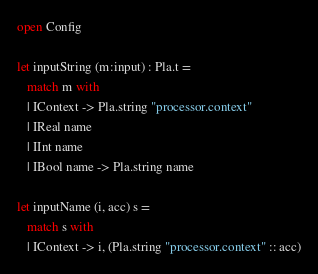Convert code to text. <code><loc_0><loc_0><loc_500><loc_500><_OCaml_>
open Config

let inputString (m:input) : Pla.t =
   match m with
   | IContext -> Pla.string "processor.context"
   | IReal name
   | IInt name
   | IBool name -> Pla.string name

let inputName (i, acc) s =
   match s with
   | IContext -> i, (Pla.string "processor.context" :: acc)</code> 